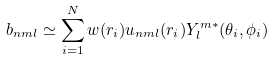Convert formula to latex. <formula><loc_0><loc_0><loc_500><loc_500>b _ { n m l } \simeq \sum _ { i = 1 } ^ { N } w ( r _ { i } ) u _ { n m l } ( r _ { i } ) Y _ { l } ^ { m * } ( \theta _ { i } , \phi _ { i } )</formula> 